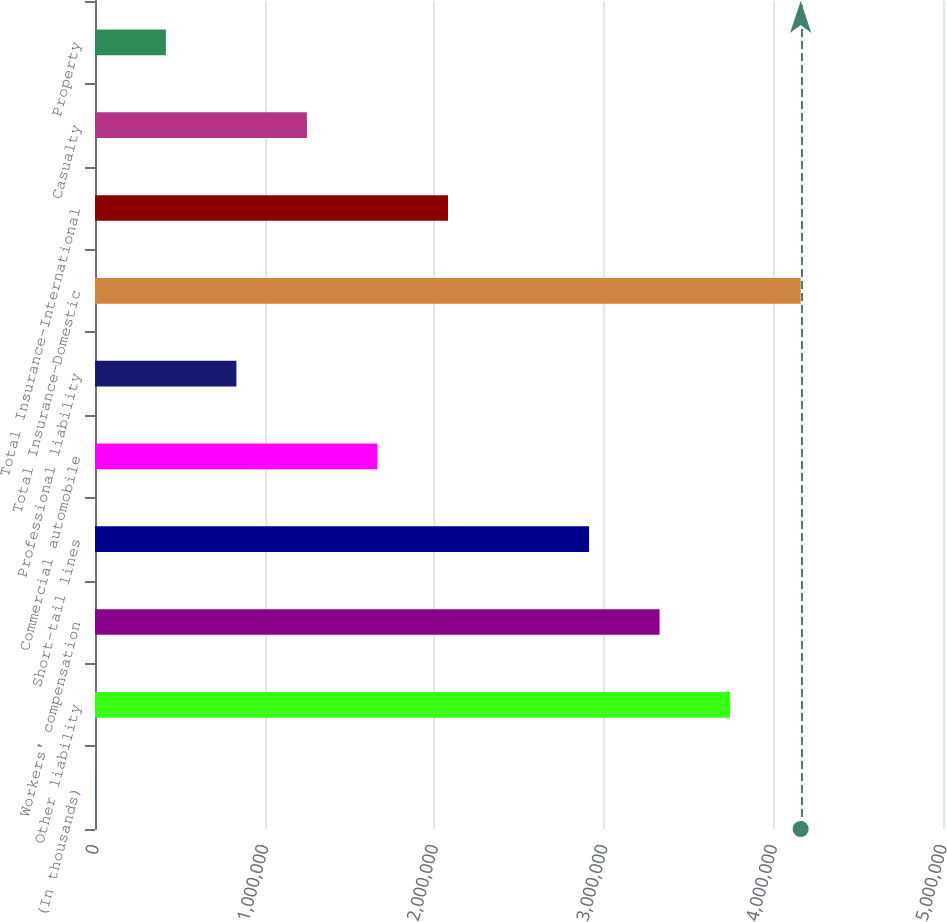Convert chart. <chart><loc_0><loc_0><loc_500><loc_500><bar_chart><fcel>(In thousands)<fcel>Other liability<fcel>Workers' compensation<fcel>Short-tail lines<fcel>Commercial automobile<fcel>Professional liability<fcel>Total Insurance-Domestic<fcel>Total Insurance-International<fcel>Casualty<fcel>Property<nl><fcel>2011<fcel>3.74498e+06<fcel>3.3291e+06<fcel>2.91321e+06<fcel>1.66555e+06<fcel>833782<fcel>4.16087e+06<fcel>2.08144e+06<fcel>1.24967e+06<fcel>417897<nl></chart> 